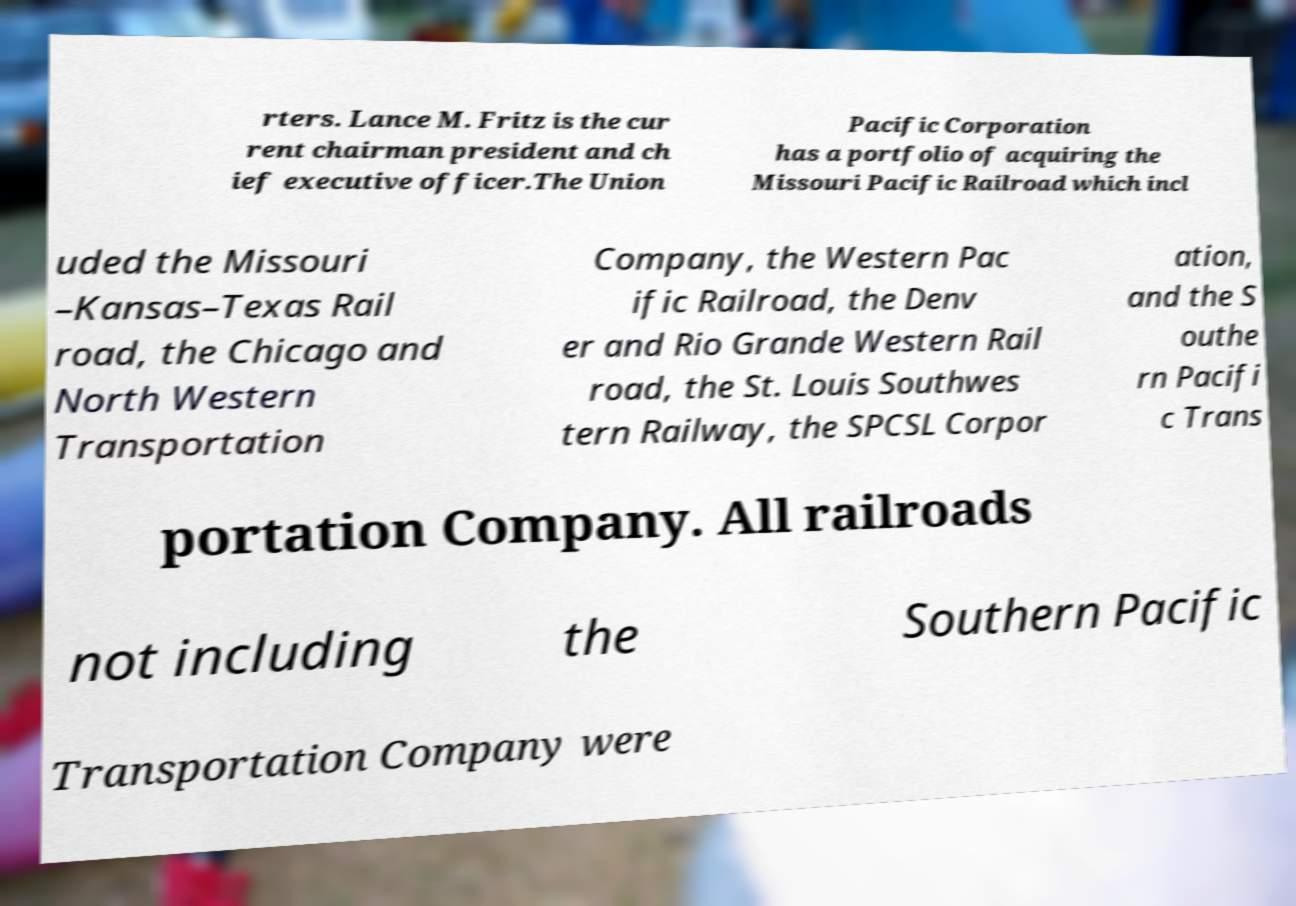Could you extract and type out the text from this image? rters. Lance M. Fritz is the cur rent chairman president and ch ief executive officer.The Union Pacific Corporation has a portfolio of acquiring the Missouri Pacific Railroad which incl uded the Missouri –Kansas–Texas Rail road, the Chicago and North Western Transportation Company, the Western Pac ific Railroad, the Denv er and Rio Grande Western Rail road, the St. Louis Southwes tern Railway, the SPCSL Corpor ation, and the S outhe rn Pacifi c Trans portation Company. All railroads not including the Southern Pacific Transportation Company were 